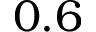Convert formula to latex. <formula><loc_0><loc_0><loc_500><loc_500>0 . 6</formula> 